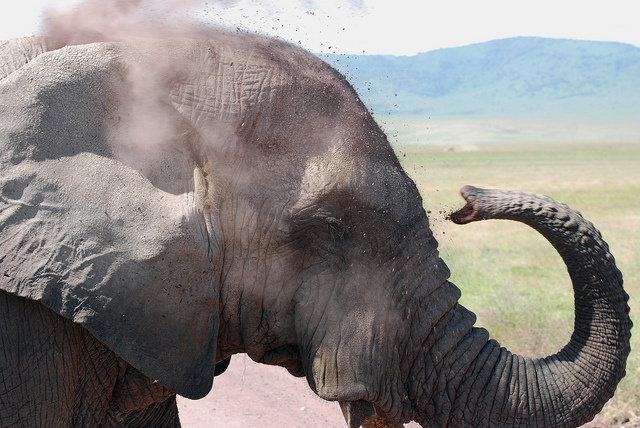Describe the objects in this image and their specific colors. I can see a elephant in white, black, gray, and darkgray tones in this image. 